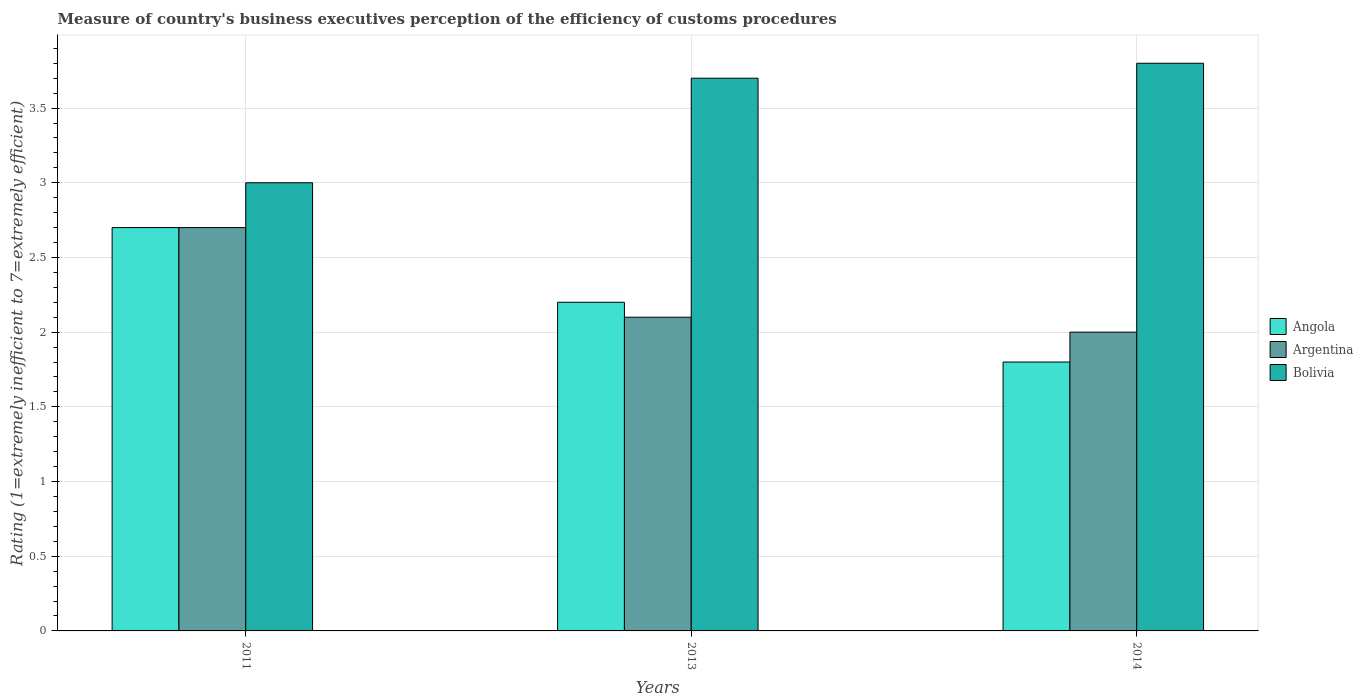How many groups of bars are there?
Provide a succinct answer. 3. Are the number of bars on each tick of the X-axis equal?
Keep it short and to the point. Yes. How many bars are there on the 2nd tick from the left?
Keep it short and to the point. 3. In how many cases, is the number of bars for a given year not equal to the number of legend labels?
Give a very brief answer. 0. What is the rating of the efficiency of customs procedure in Argentina in 2013?
Provide a succinct answer. 2.1. Across all years, what is the maximum rating of the efficiency of customs procedure in Angola?
Give a very brief answer. 2.7. Across all years, what is the minimum rating of the efficiency of customs procedure in Angola?
Provide a short and direct response. 1.8. What is the total rating of the efficiency of customs procedure in Bolivia in the graph?
Offer a terse response. 10.5. What is the average rating of the efficiency of customs procedure in Angola per year?
Give a very brief answer. 2.23. In the year 2014, what is the difference between the rating of the efficiency of customs procedure in Bolivia and rating of the efficiency of customs procedure in Angola?
Your answer should be compact. 2. What is the ratio of the rating of the efficiency of customs procedure in Bolivia in 2011 to that in 2013?
Keep it short and to the point. 0.81. What is the difference between the highest and the second highest rating of the efficiency of customs procedure in Bolivia?
Offer a very short reply. 0.1. What is the difference between the highest and the lowest rating of the efficiency of customs procedure in Bolivia?
Ensure brevity in your answer.  0.8. In how many years, is the rating of the efficiency of customs procedure in Bolivia greater than the average rating of the efficiency of customs procedure in Bolivia taken over all years?
Your response must be concise. 2. What does the 1st bar from the left in 2011 represents?
Offer a terse response. Angola. What does the 3rd bar from the right in 2011 represents?
Ensure brevity in your answer.  Angola. Are the values on the major ticks of Y-axis written in scientific E-notation?
Offer a very short reply. No. Does the graph contain any zero values?
Your answer should be very brief. No. Does the graph contain grids?
Your response must be concise. Yes. Where does the legend appear in the graph?
Make the answer very short. Center right. How are the legend labels stacked?
Provide a succinct answer. Vertical. What is the title of the graph?
Keep it short and to the point. Measure of country's business executives perception of the efficiency of customs procedures. Does "Burundi" appear as one of the legend labels in the graph?
Keep it short and to the point. No. What is the label or title of the Y-axis?
Your answer should be compact. Rating (1=extremely inefficient to 7=extremely efficient). What is the Rating (1=extremely inefficient to 7=extremely efficient) in Angola in 2011?
Provide a short and direct response. 2.7. What is the Rating (1=extremely inefficient to 7=extremely efficient) in Angola in 2013?
Make the answer very short. 2.2. What is the Rating (1=extremely inefficient to 7=extremely efficient) in Bolivia in 2013?
Keep it short and to the point. 3.7. What is the Rating (1=extremely inefficient to 7=extremely efficient) in Angola in 2014?
Keep it short and to the point. 1.8. What is the Rating (1=extremely inefficient to 7=extremely efficient) of Argentina in 2014?
Your response must be concise. 2. Across all years, what is the minimum Rating (1=extremely inefficient to 7=extremely efficient) of Angola?
Provide a short and direct response. 1.8. Across all years, what is the minimum Rating (1=extremely inefficient to 7=extremely efficient) of Bolivia?
Make the answer very short. 3. What is the total Rating (1=extremely inefficient to 7=extremely efficient) in Argentina in the graph?
Provide a short and direct response. 6.8. What is the difference between the Rating (1=extremely inefficient to 7=extremely efficient) in Argentina in 2011 and that in 2013?
Keep it short and to the point. 0.6. What is the difference between the Rating (1=extremely inefficient to 7=extremely efficient) of Bolivia in 2011 and that in 2013?
Offer a terse response. -0.7. What is the difference between the Rating (1=extremely inefficient to 7=extremely efficient) in Angola in 2011 and that in 2014?
Ensure brevity in your answer.  0.9. What is the difference between the Rating (1=extremely inefficient to 7=extremely efficient) of Argentina in 2011 and that in 2014?
Your answer should be very brief. 0.7. What is the difference between the Rating (1=extremely inefficient to 7=extremely efficient) of Bolivia in 2011 and that in 2014?
Provide a short and direct response. -0.8. What is the difference between the Rating (1=extremely inefficient to 7=extremely efficient) of Angola in 2013 and that in 2014?
Keep it short and to the point. 0.4. What is the difference between the Rating (1=extremely inefficient to 7=extremely efficient) in Argentina in 2013 and that in 2014?
Give a very brief answer. 0.1. What is the difference between the Rating (1=extremely inefficient to 7=extremely efficient) of Angola in 2011 and the Rating (1=extremely inefficient to 7=extremely efficient) of Argentina in 2013?
Keep it short and to the point. 0.6. What is the difference between the Rating (1=extremely inefficient to 7=extremely efficient) in Argentina in 2011 and the Rating (1=extremely inefficient to 7=extremely efficient) in Bolivia in 2013?
Give a very brief answer. -1. What is the difference between the Rating (1=extremely inefficient to 7=extremely efficient) of Angola in 2011 and the Rating (1=extremely inefficient to 7=extremely efficient) of Bolivia in 2014?
Offer a terse response. -1.1. What is the difference between the Rating (1=extremely inefficient to 7=extremely efficient) in Argentina in 2011 and the Rating (1=extremely inefficient to 7=extremely efficient) in Bolivia in 2014?
Provide a succinct answer. -1.1. What is the difference between the Rating (1=extremely inefficient to 7=extremely efficient) in Angola in 2013 and the Rating (1=extremely inefficient to 7=extremely efficient) in Bolivia in 2014?
Keep it short and to the point. -1.6. What is the difference between the Rating (1=extremely inefficient to 7=extremely efficient) of Argentina in 2013 and the Rating (1=extremely inefficient to 7=extremely efficient) of Bolivia in 2014?
Your answer should be very brief. -1.7. What is the average Rating (1=extremely inefficient to 7=extremely efficient) of Angola per year?
Provide a succinct answer. 2.23. What is the average Rating (1=extremely inefficient to 7=extremely efficient) in Argentina per year?
Make the answer very short. 2.27. What is the average Rating (1=extremely inefficient to 7=extremely efficient) in Bolivia per year?
Your answer should be compact. 3.5. In the year 2011, what is the difference between the Rating (1=extremely inefficient to 7=extremely efficient) in Angola and Rating (1=extremely inefficient to 7=extremely efficient) in Argentina?
Keep it short and to the point. 0. In the year 2011, what is the difference between the Rating (1=extremely inefficient to 7=extremely efficient) in Argentina and Rating (1=extremely inefficient to 7=extremely efficient) in Bolivia?
Ensure brevity in your answer.  -0.3. In the year 2013, what is the difference between the Rating (1=extremely inefficient to 7=extremely efficient) of Angola and Rating (1=extremely inefficient to 7=extremely efficient) of Argentina?
Offer a very short reply. 0.1. In the year 2013, what is the difference between the Rating (1=extremely inefficient to 7=extremely efficient) of Angola and Rating (1=extremely inefficient to 7=extremely efficient) of Bolivia?
Offer a terse response. -1.5. In the year 2014, what is the difference between the Rating (1=extremely inefficient to 7=extremely efficient) in Angola and Rating (1=extremely inefficient to 7=extremely efficient) in Argentina?
Provide a succinct answer. -0.2. What is the ratio of the Rating (1=extremely inefficient to 7=extremely efficient) of Angola in 2011 to that in 2013?
Offer a very short reply. 1.23. What is the ratio of the Rating (1=extremely inefficient to 7=extremely efficient) in Argentina in 2011 to that in 2013?
Provide a succinct answer. 1.29. What is the ratio of the Rating (1=extremely inefficient to 7=extremely efficient) of Bolivia in 2011 to that in 2013?
Provide a short and direct response. 0.81. What is the ratio of the Rating (1=extremely inefficient to 7=extremely efficient) in Angola in 2011 to that in 2014?
Make the answer very short. 1.5. What is the ratio of the Rating (1=extremely inefficient to 7=extremely efficient) of Argentina in 2011 to that in 2014?
Ensure brevity in your answer.  1.35. What is the ratio of the Rating (1=extremely inefficient to 7=extremely efficient) of Bolivia in 2011 to that in 2014?
Offer a terse response. 0.79. What is the ratio of the Rating (1=extremely inefficient to 7=extremely efficient) in Angola in 2013 to that in 2014?
Your response must be concise. 1.22. What is the ratio of the Rating (1=extremely inefficient to 7=extremely efficient) of Bolivia in 2013 to that in 2014?
Your answer should be compact. 0.97. What is the difference between the highest and the second highest Rating (1=extremely inefficient to 7=extremely efficient) in Angola?
Ensure brevity in your answer.  0.5. What is the difference between the highest and the lowest Rating (1=extremely inefficient to 7=extremely efficient) in Angola?
Ensure brevity in your answer.  0.9. 